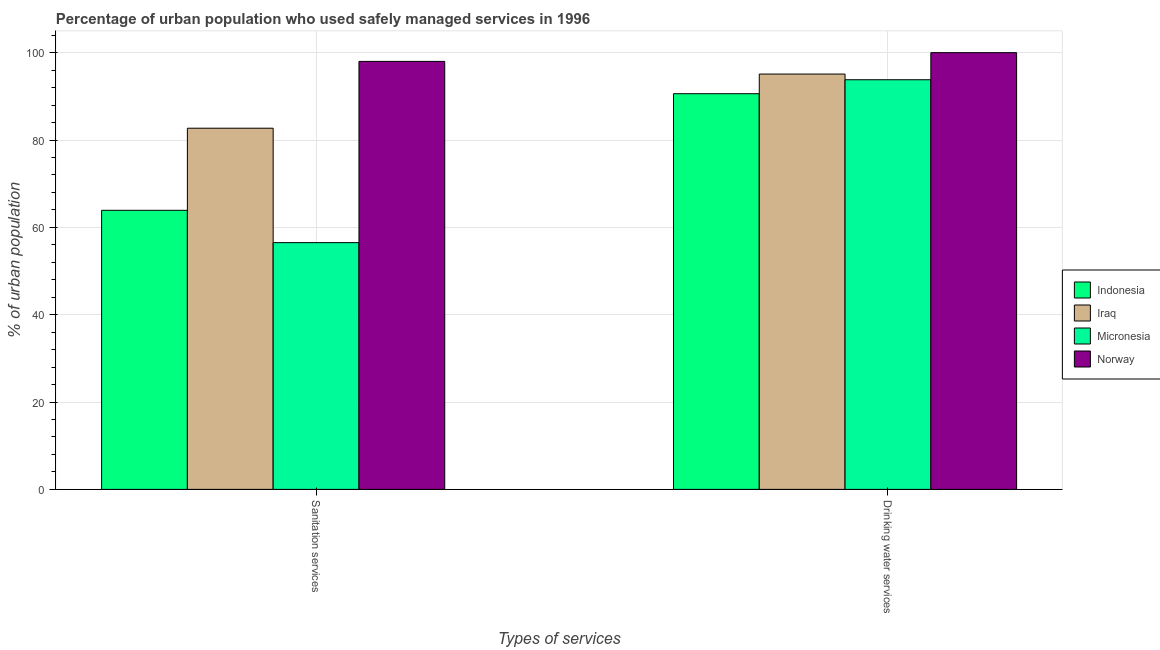How many different coloured bars are there?
Give a very brief answer. 4. How many groups of bars are there?
Make the answer very short. 2. Are the number of bars per tick equal to the number of legend labels?
Your response must be concise. Yes. How many bars are there on the 1st tick from the right?
Make the answer very short. 4. What is the label of the 2nd group of bars from the left?
Provide a short and direct response. Drinking water services. Across all countries, what is the maximum percentage of urban population who used drinking water services?
Your answer should be very brief. 100. Across all countries, what is the minimum percentage of urban population who used drinking water services?
Keep it short and to the point. 90.6. What is the total percentage of urban population who used drinking water services in the graph?
Your answer should be very brief. 379.5. What is the difference between the percentage of urban population who used drinking water services in Indonesia and that in Norway?
Give a very brief answer. -9.4. What is the difference between the percentage of urban population who used drinking water services in Micronesia and the percentage of urban population who used sanitation services in Iraq?
Ensure brevity in your answer.  11.1. What is the average percentage of urban population who used sanitation services per country?
Make the answer very short. 75.28. What is the difference between the percentage of urban population who used sanitation services and percentage of urban population who used drinking water services in Micronesia?
Provide a succinct answer. -37.3. What is the ratio of the percentage of urban population who used sanitation services in Norway to that in Micronesia?
Your response must be concise. 1.73. Is the percentage of urban population who used drinking water services in Norway less than that in Iraq?
Provide a succinct answer. No. In how many countries, is the percentage of urban population who used sanitation services greater than the average percentage of urban population who used sanitation services taken over all countries?
Your answer should be very brief. 2. What does the 4th bar from the left in Drinking water services represents?
Offer a terse response. Norway. How many bars are there?
Ensure brevity in your answer.  8. What is the difference between two consecutive major ticks on the Y-axis?
Make the answer very short. 20. Does the graph contain any zero values?
Your answer should be compact. No. Does the graph contain grids?
Make the answer very short. Yes. Where does the legend appear in the graph?
Provide a succinct answer. Center right. How many legend labels are there?
Your answer should be compact. 4. How are the legend labels stacked?
Your answer should be very brief. Vertical. What is the title of the graph?
Provide a succinct answer. Percentage of urban population who used safely managed services in 1996. Does "Senegal" appear as one of the legend labels in the graph?
Keep it short and to the point. No. What is the label or title of the X-axis?
Your response must be concise. Types of services. What is the label or title of the Y-axis?
Offer a very short reply. % of urban population. What is the % of urban population in Indonesia in Sanitation services?
Your answer should be compact. 63.9. What is the % of urban population in Iraq in Sanitation services?
Provide a short and direct response. 82.7. What is the % of urban population of Micronesia in Sanitation services?
Your answer should be compact. 56.5. What is the % of urban population in Indonesia in Drinking water services?
Provide a succinct answer. 90.6. What is the % of urban population of Iraq in Drinking water services?
Ensure brevity in your answer.  95.1. What is the % of urban population of Micronesia in Drinking water services?
Offer a terse response. 93.8. Across all Types of services, what is the maximum % of urban population in Indonesia?
Your answer should be compact. 90.6. Across all Types of services, what is the maximum % of urban population of Iraq?
Provide a short and direct response. 95.1. Across all Types of services, what is the maximum % of urban population of Micronesia?
Offer a terse response. 93.8. Across all Types of services, what is the maximum % of urban population in Norway?
Give a very brief answer. 100. Across all Types of services, what is the minimum % of urban population in Indonesia?
Provide a succinct answer. 63.9. Across all Types of services, what is the minimum % of urban population of Iraq?
Offer a very short reply. 82.7. Across all Types of services, what is the minimum % of urban population of Micronesia?
Offer a very short reply. 56.5. Across all Types of services, what is the minimum % of urban population of Norway?
Make the answer very short. 98. What is the total % of urban population in Indonesia in the graph?
Your answer should be compact. 154.5. What is the total % of urban population of Iraq in the graph?
Provide a succinct answer. 177.8. What is the total % of urban population in Micronesia in the graph?
Make the answer very short. 150.3. What is the total % of urban population in Norway in the graph?
Give a very brief answer. 198. What is the difference between the % of urban population of Indonesia in Sanitation services and that in Drinking water services?
Give a very brief answer. -26.7. What is the difference between the % of urban population in Iraq in Sanitation services and that in Drinking water services?
Keep it short and to the point. -12.4. What is the difference between the % of urban population of Micronesia in Sanitation services and that in Drinking water services?
Keep it short and to the point. -37.3. What is the difference between the % of urban population in Indonesia in Sanitation services and the % of urban population in Iraq in Drinking water services?
Your answer should be compact. -31.2. What is the difference between the % of urban population in Indonesia in Sanitation services and the % of urban population in Micronesia in Drinking water services?
Your answer should be compact. -29.9. What is the difference between the % of urban population of Indonesia in Sanitation services and the % of urban population of Norway in Drinking water services?
Ensure brevity in your answer.  -36.1. What is the difference between the % of urban population of Iraq in Sanitation services and the % of urban population of Micronesia in Drinking water services?
Ensure brevity in your answer.  -11.1. What is the difference between the % of urban population of Iraq in Sanitation services and the % of urban population of Norway in Drinking water services?
Provide a short and direct response. -17.3. What is the difference between the % of urban population of Micronesia in Sanitation services and the % of urban population of Norway in Drinking water services?
Your response must be concise. -43.5. What is the average % of urban population of Indonesia per Types of services?
Your answer should be very brief. 77.25. What is the average % of urban population of Iraq per Types of services?
Your response must be concise. 88.9. What is the average % of urban population of Micronesia per Types of services?
Ensure brevity in your answer.  75.15. What is the difference between the % of urban population of Indonesia and % of urban population of Iraq in Sanitation services?
Keep it short and to the point. -18.8. What is the difference between the % of urban population of Indonesia and % of urban population of Norway in Sanitation services?
Give a very brief answer. -34.1. What is the difference between the % of urban population of Iraq and % of urban population of Micronesia in Sanitation services?
Offer a terse response. 26.2. What is the difference between the % of urban population of Iraq and % of urban population of Norway in Sanitation services?
Offer a very short reply. -15.3. What is the difference between the % of urban population in Micronesia and % of urban population in Norway in Sanitation services?
Keep it short and to the point. -41.5. What is the difference between the % of urban population of Indonesia and % of urban population of Norway in Drinking water services?
Offer a terse response. -9.4. What is the difference between the % of urban population of Iraq and % of urban population of Micronesia in Drinking water services?
Offer a terse response. 1.3. What is the difference between the % of urban population in Iraq and % of urban population in Norway in Drinking water services?
Ensure brevity in your answer.  -4.9. What is the difference between the % of urban population of Micronesia and % of urban population of Norway in Drinking water services?
Give a very brief answer. -6.2. What is the ratio of the % of urban population of Indonesia in Sanitation services to that in Drinking water services?
Give a very brief answer. 0.71. What is the ratio of the % of urban population of Iraq in Sanitation services to that in Drinking water services?
Offer a very short reply. 0.87. What is the ratio of the % of urban population of Micronesia in Sanitation services to that in Drinking water services?
Your answer should be compact. 0.6. What is the difference between the highest and the second highest % of urban population of Indonesia?
Offer a terse response. 26.7. What is the difference between the highest and the second highest % of urban population of Micronesia?
Offer a very short reply. 37.3. What is the difference between the highest and the lowest % of urban population of Indonesia?
Your response must be concise. 26.7. What is the difference between the highest and the lowest % of urban population in Micronesia?
Keep it short and to the point. 37.3. 